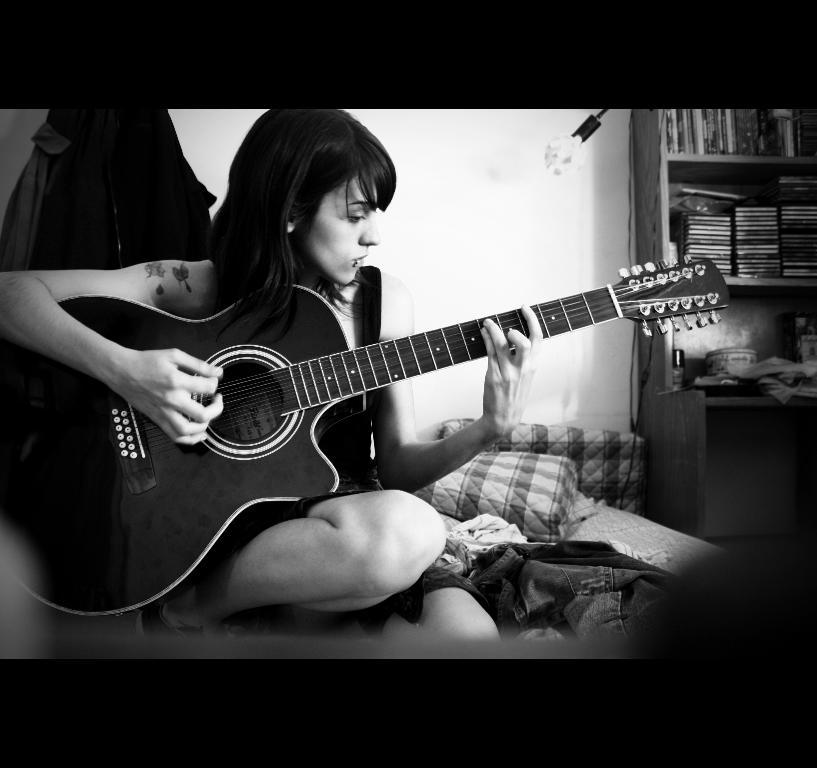What is the color scheme of the image? The image is black and white. What is the lady in the image doing? The lady is playing a musical instrument. What else can be seen in the image besides the lady and her instrument? There are clothes visible in the image, as well as shelves with objects. What type of structure is present in the image? There is a wall in the image. What type of card is being used to play the musical instrument in the image? There is no card present in the image, and the lady is not using a card to play the musical instrument. 